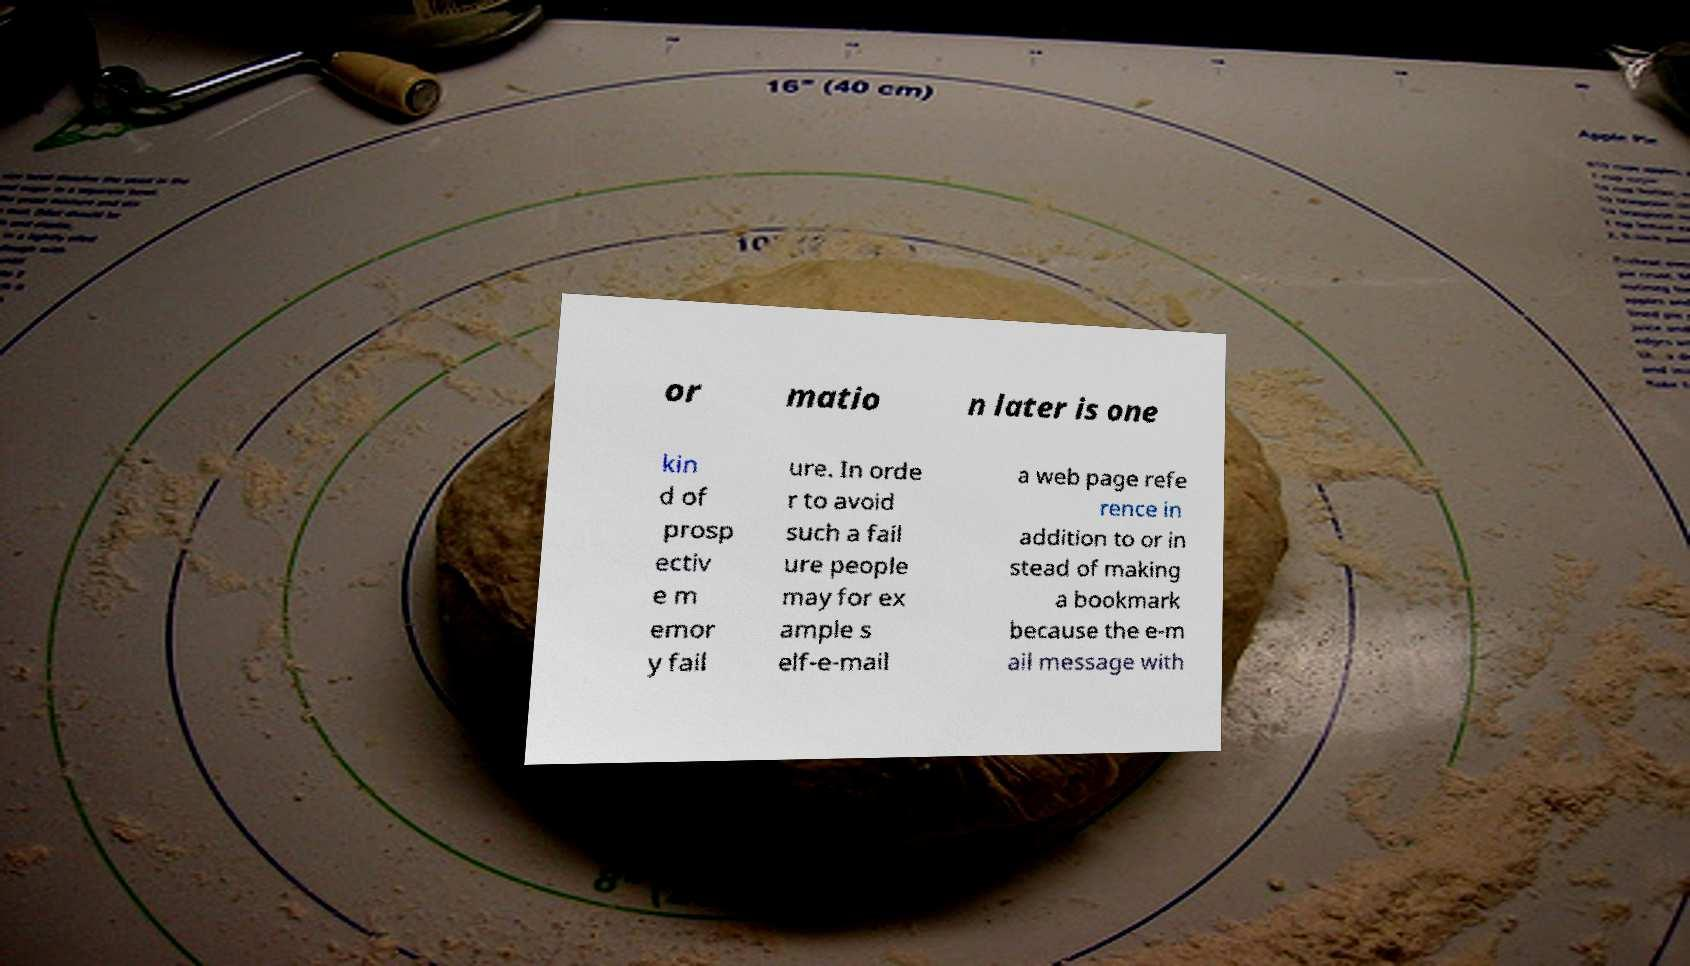Can you accurately transcribe the text from the provided image for me? or matio n later is one kin d of prosp ectiv e m emor y fail ure. In orde r to avoid such a fail ure people may for ex ample s elf-e-mail a web page refe rence in addition to or in stead of making a bookmark because the e-m ail message with 